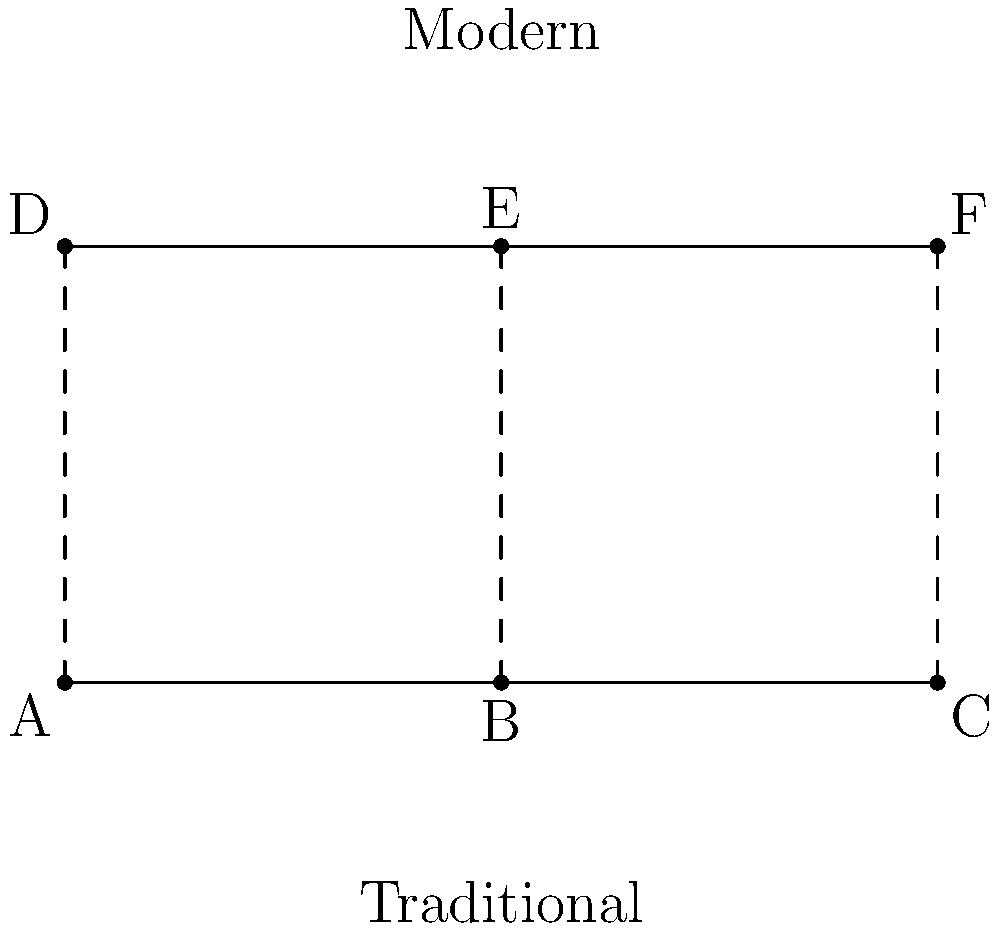The diagram above shows stick figure representations of traditional and modern Okinawan dance poses. If the angle between the arms in the traditional pose (∠ABC) is 120°, and the modern interpretation (∠DEF) reduces this angle by 25%, what is the new angle in the modern pose? To solve this problem, let's follow these steps:

1. Identify the given information:
   - Traditional pose angle (∠ABC) = 120°
   - Modern pose reduces this angle by 25%

2. Calculate the reduction in degrees:
   - 25% of 120° = 0.25 × 120° = 30°

3. Subtract the reduction from the original angle:
   - Modern pose angle = Traditional pose angle - Reduction
   - Modern pose angle = 120° - 30° = 90°

Therefore, the new angle in the modern pose (∠DEF) is 90°.
Answer: 90° 